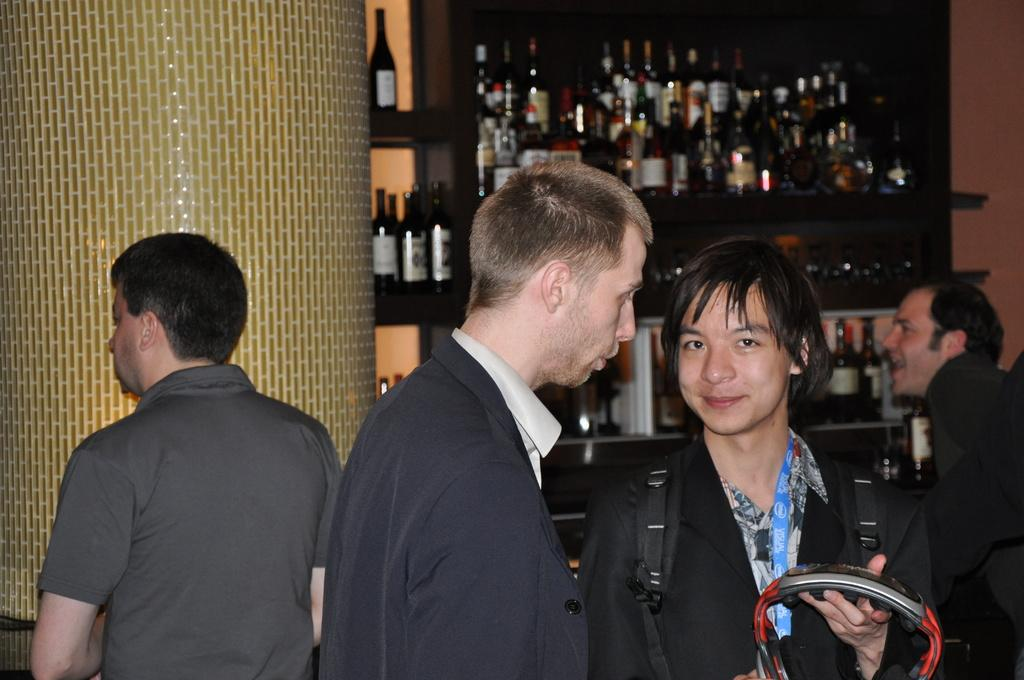How many people are in the image? There is a group of people in the image. Can you describe the person carrying a bag? The person carrying the bag is holding an object and smiling. What can be seen in the background of the image? There are bottles visible in the background of the image. What does the person carrying the bag regret in the image? There is no indication in the image that the person carrying the bag has any regrets. 